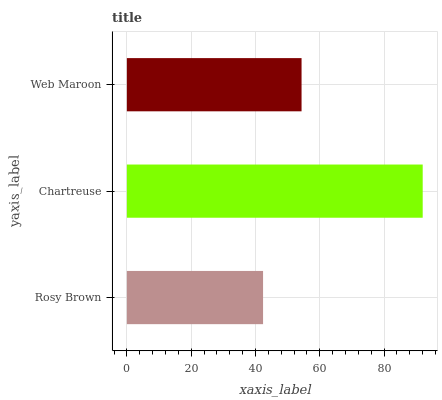Is Rosy Brown the minimum?
Answer yes or no. Yes. Is Chartreuse the maximum?
Answer yes or no. Yes. Is Web Maroon the minimum?
Answer yes or no. No. Is Web Maroon the maximum?
Answer yes or no. No. Is Chartreuse greater than Web Maroon?
Answer yes or no. Yes. Is Web Maroon less than Chartreuse?
Answer yes or no. Yes. Is Web Maroon greater than Chartreuse?
Answer yes or no. No. Is Chartreuse less than Web Maroon?
Answer yes or no. No. Is Web Maroon the high median?
Answer yes or no. Yes. Is Web Maroon the low median?
Answer yes or no. Yes. Is Chartreuse the high median?
Answer yes or no. No. Is Chartreuse the low median?
Answer yes or no. No. 